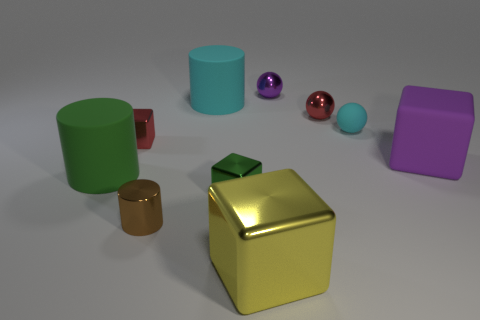Is there any other thing that is the same color as the big metallic block?
Make the answer very short. No. There is a tiny red metallic object on the left side of the tiny purple metallic object that is to the right of the green matte cylinder; is there a purple metallic ball that is in front of it?
Make the answer very short. No. What is the shape of the small purple thing?
Ensure brevity in your answer.  Sphere. Are there fewer big yellow things that are in front of the large yellow thing than tiny rubber balls?
Your answer should be very brief. Yes. Is there a small purple metal object of the same shape as the green metal thing?
Keep it short and to the point. No. There is a yellow thing that is the same size as the green rubber cylinder; what shape is it?
Provide a succinct answer. Cube. How many things are either brown shiny objects or cyan cylinders?
Your answer should be compact. 2. Are there any yellow shiny balls?
Provide a succinct answer. No. Is the number of large purple matte cylinders less than the number of small brown metal objects?
Ensure brevity in your answer.  Yes. Is there a brown shiny object of the same size as the red sphere?
Keep it short and to the point. Yes. 